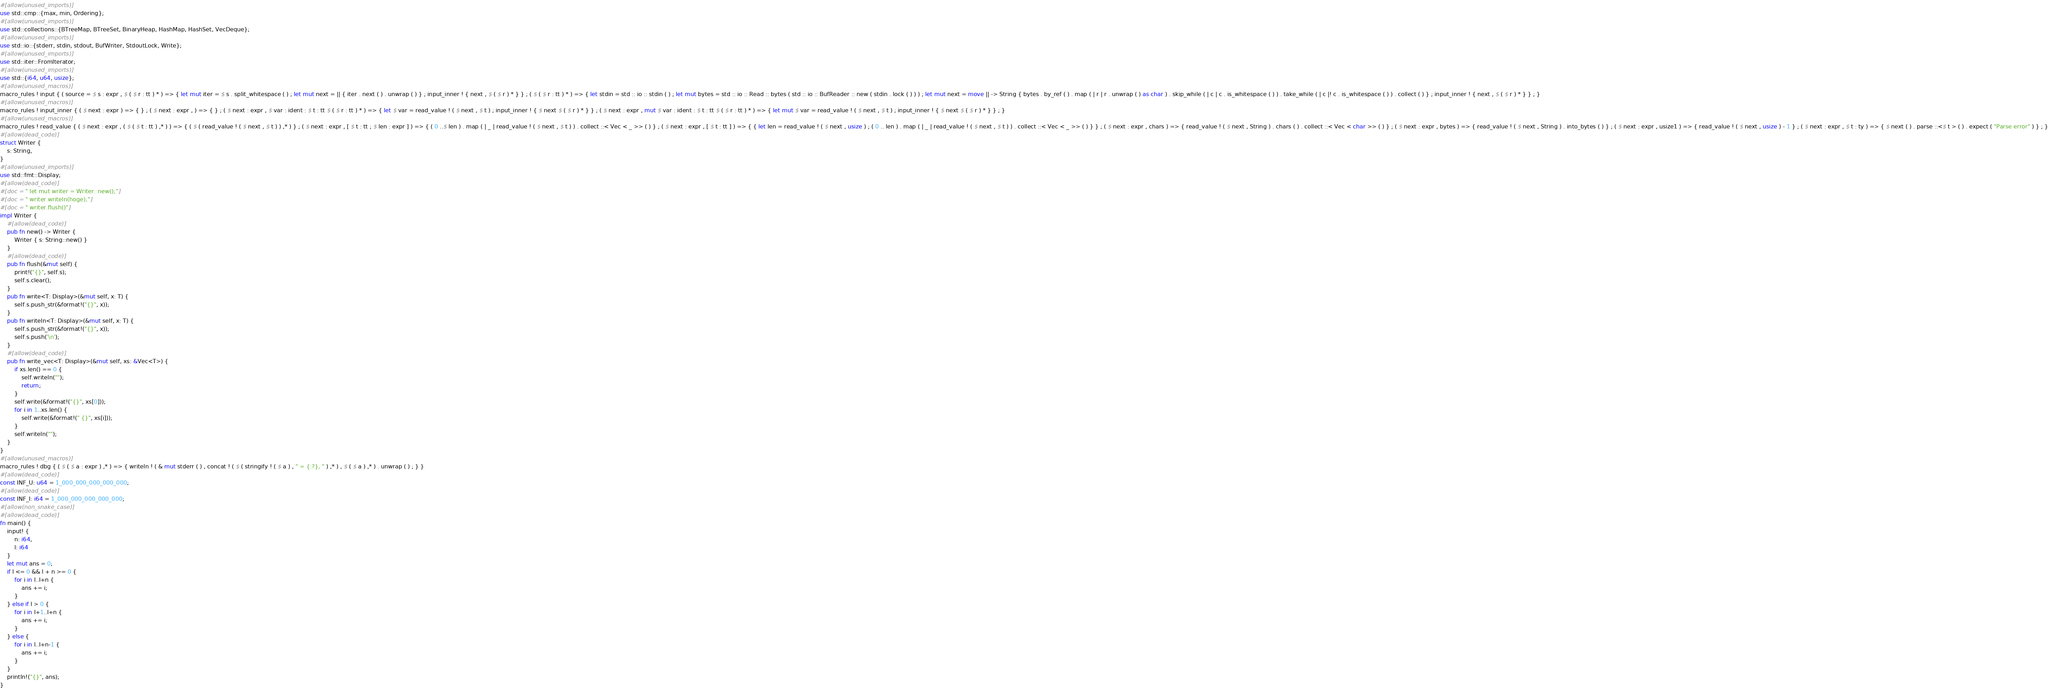Convert code to text. <code><loc_0><loc_0><loc_500><loc_500><_Rust_>#[allow(unused_imports)]
use std::cmp::{max, min, Ordering};
#[allow(unused_imports)]
use std::collections::{BTreeMap, BTreeSet, BinaryHeap, HashMap, HashSet, VecDeque};
#[allow(unused_imports)]
use std::io::{stderr, stdin, stdout, BufWriter, StdoutLock, Write};
#[allow(unused_imports)]
use std::iter::FromIterator;
#[allow(unused_imports)]
use std::{i64, u64, usize};
#[allow(unused_macros)]
macro_rules ! input { ( source = $ s : expr , $ ( $ r : tt ) * ) => { let mut iter = $ s . split_whitespace ( ) ; let mut next = || { iter . next ( ) . unwrap ( ) } ; input_inner ! { next , $ ( $ r ) * } } ; ( $ ( $ r : tt ) * ) => { let stdin = std :: io :: stdin ( ) ; let mut bytes = std :: io :: Read :: bytes ( std :: io :: BufReader :: new ( stdin . lock ( ) ) ) ; let mut next = move || -> String { bytes . by_ref ( ) . map ( | r | r . unwrap ( ) as char ) . skip_while ( | c | c . is_whitespace ( ) ) . take_while ( | c |! c . is_whitespace ( ) ) . collect ( ) } ; input_inner ! { next , $ ( $ r ) * } } ; }
#[allow(unused_macros)]
macro_rules ! input_inner { ( $ next : expr ) => { } ; ( $ next : expr , ) => { } ; ( $ next : expr , $ var : ident : $ t : tt $ ( $ r : tt ) * ) => { let $ var = read_value ! ( $ next , $ t ) ; input_inner ! { $ next $ ( $ r ) * } } ; ( $ next : expr , mut $ var : ident : $ t : tt $ ( $ r : tt ) * ) => { let mut $ var = read_value ! ( $ next , $ t ) ; input_inner ! { $ next $ ( $ r ) * } } ; }
#[allow(unused_macros)]
macro_rules ! read_value { ( $ next : expr , ( $ ( $ t : tt ) ,* ) ) => { ( $ ( read_value ! ( $ next , $ t ) ) ,* ) } ; ( $ next : expr , [ $ t : tt ; $ len : expr ] ) => { ( 0 ..$ len ) . map ( | _ | read_value ! ( $ next , $ t ) ) . collect ::< Vec < _ >> ( ) } ; ( $ next : expr , [ $ t : tt ] ) => { { let len = read_value ! ( $ next , usize ) ; ( 0 .. len ) . map ( | _ | read_value ! ( $ next , $ t ) ) . collect ::< Vec < _ >> ( ) } } ; ( $ next : expr , chars ) => { read_value ! ( $ next , String ) . chars ( ) . collect ::< Vec < char >> ( ) } ; ( $ next : expr , bytes ) => { read_value ! ( $ next , String ) . into_bytes ( ) } ; ( $ next : expr , usize1 ) => { read_value ! ( $ next , usize ) - 1 } ; ( $ next : expr , $ t : ty ) => { $ next ( ) . parse ::<$ t > ( ) . expect ( "Parse error" ) } ; }
#[allow(dead_code)]
struct Writer {
    s: String,
}
#[allow(unused_imports)]
use std::fmt::Display;
#[allow(dead_code)]
#[doc = " let mut writer = Writer::new();"]
#[doc = " writer.writeln(hoge);"]
#[doc = " writer.flush()"]
impl Writer {
    #[allow(dead_code)]
    pub fn new() -> Writer {
        Writer { s: String::new() }
    }
    #[allow(dead_code)]
    pub fn flush(&mut self) {
        print!("{}", self.s);
        self.s.clear();
    }
    pub fn write<T: Display>(&mut self, x: T) {
        self.s.push_str(&format!("{}", x));
    }
    pub fn writeln<T: Display>(&mut self, x: T) {
        self.s.push_str(&format!("{}", x));
        self.s.push('\n');
    }
    #[allow(dead_code)]
    pub fn write_vec<T: Display>(&mut self, xs: &Vec<T>) {
        if xs.len() == 0 {
            self.writeln("");
            return;
        }
        self.write(&format!("{}", xs[0]));
        for i in 1..xs.len() {
            self.write(&format!(" {}", xs[i]));
        }
        self.writeln("");
    }
}
#[allow(unused_macros)]
macro_rules ! dbg { ( $ ( $ a : expr ) ,* ) => { writeln ! ( & mut stderr ( ) , concat ! ( $ ( stringify ! ( $ a ) , " = {:?}, " ) ,* ) , $ ( $ a ) ,* ) . unwrap ( ) ; } }
#[allow(dead_code)]
const INF_U: u64 = 1_000_000_000_000_000;
#[allow(dead_code)]
const INF_I: i64 = 1_000_000_000_000_000;
#[allow(non_snake_case)]
#[allow(dead_code)]
fn main() {
    input! {
        n: i64,
        l: i64
    }
    let mut ans = 0;
    if l <= 0 && l + n >= 0 {
        for i in l..l+n {
            ans += i;
        }
    } else if l > 0 {
        for i in l+1..l+n {
            ans += i;
        }
    } else {
        for i in l..l+n-1 {
            ans += i;
        }
    }
    println!("{}", ans);
}</code> 